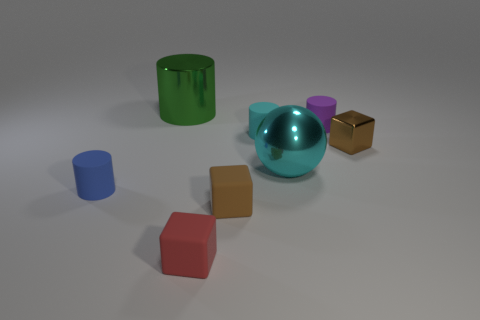What material is the small cylinder that is in front of the cyan matte cylinder?
Make the answer very short. Rubber. There is a cyan shiny sphere; are there any brown things behind it?
Ensure brevity in your answer.  Yes. Do the cyan matte object and the brown rubber block have the same size?
Your answer should be very brief. Yes. What number of tiny red things are made of the same material as the tiny cyan object?
Your answer should be compact. 1. How big is the cylinder that is on the left side of the big shiny thing that is behind the purple object?
Offer a very short reply. Small. What is the color of the tiny cube that is on the left side of the small shiny thing and on the right side of the tiny red block?
Provide a short and direct response. Brown. Do the green shiny object and the brown rubber thing have the same shape?
Ensure brevity in your answer.  No. What size is the object that is the same color as the big metallic ball?
Make the answer very short. Small. There is a shiny thing right of the large metallic object in front of the metallic cube; what shape is it?
Give a very brief answer. Cube. There is a big green thing; does it have the same shape as the cyan thing left of the cyan metallic sphere?
Offer a very short reply. Yes. 